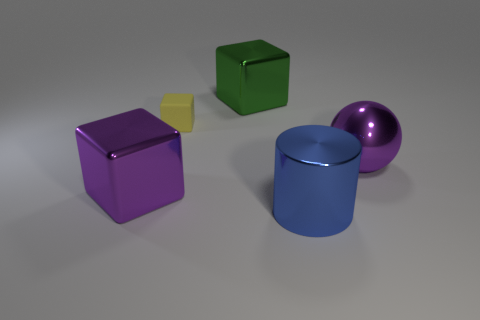Subtract all green blocks. How many blocks are left? 2 Add 4 large yellow cubes. How many objects exist? 9 Subtract all blocks. How many objects are left? 2 Subtract all cyan blocks. Subtract all purple spheres. How many blocks are left? 3 Add 1 big green metal cubes. How many big green metal cubes exist? 2 Subtract 0 brown spheres. How many objects are left? 5 Subtract all large blue metal objects. Subtract all yellow rubber cubes. How many objects are left? 3 Add 5 blue metallic things. How many blue metallic things are left? 6 